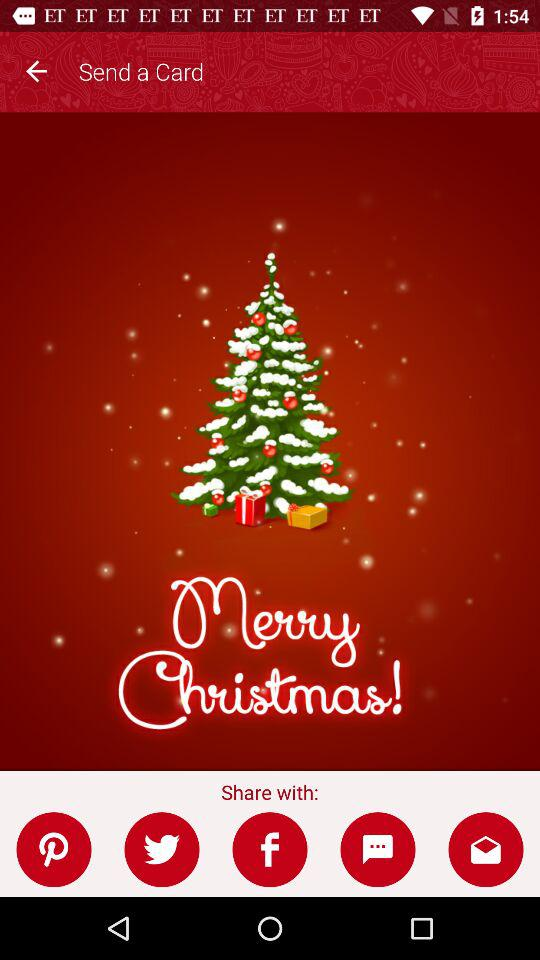What are the different options available for sharing the card? The different available options for sharing are: "Pinterest", "Twitter", "Facebook", "Messaging", and "Email". 